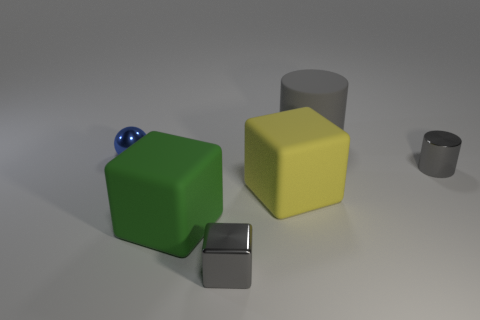Are any small blue things visible?
Give a very brief answer. Yes. What number of big yellow rubber things are in front of the big thing on the left side of the yellow rubber cube?
Your answer should be compact. 0. There is a gray shiny object that is right of the big matte cylinder; what is its shape?
Offer a terse response. Cylinder. The cylinder in front of the small object left of the tiny gray object that is in front of the green block is made of what material?
Make the answer very short. Metal. What material is the gray thing that is the same shape as the green matte object?
Keep it short and to the point. Metal. What color is the small shiny sphere?
Make the answer very short. Blue. What is the color of the small object in front of the small gray metallic object behind the large green object?
Make the answer very short. Gray. Do the small metallic cylinder and the metallic sphere that is left of the large gray rubber cylinder have the same color?
Provide a short and direct response. No. What number of tiny cylinders are left of the gray metal thing left of the rubber cylinder on the right side of the blue metal ball?
Ensure brevity in your answer.  0. There is a gray rubber object; are there any gray rubber things on the right side of it?
Your answer should be very brief. No. 